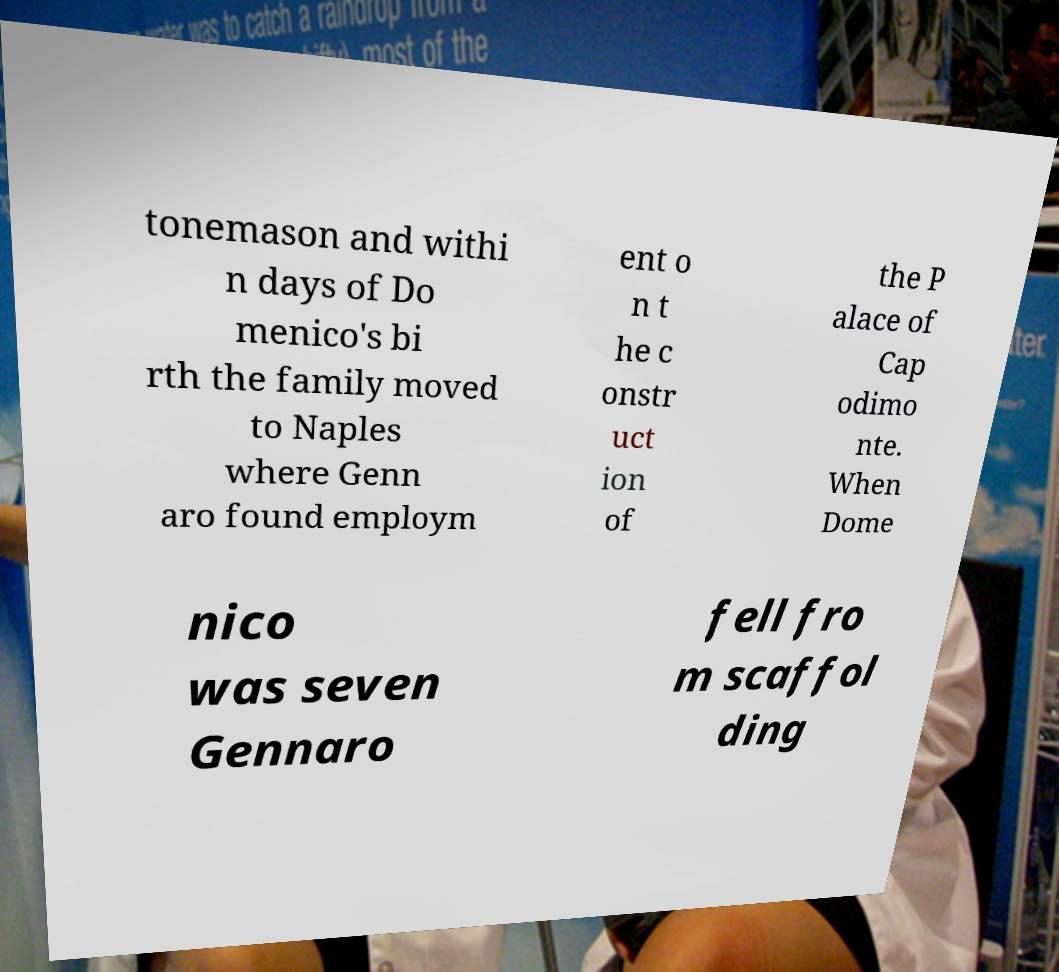For documentation purposes, I need the text within this image transcribed. Could you provide that? tonemason and withi n days of Do menico's bi rth the family moved to Naples where Genn aro found employm ent o n t he c onstr uct ion of the P alace of Cap odimo nte. When Dome nico was seven Gennaro fell fro m scaffol ding 